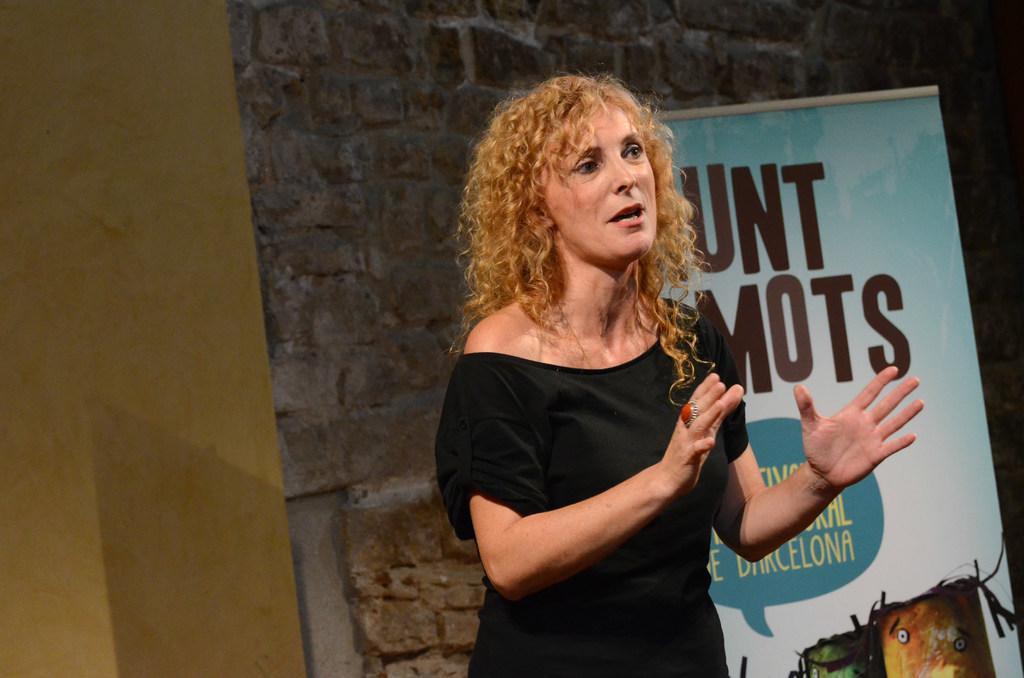Can you describe this image briefly? In this image we can see a person standing and talking. In the background, we can see the banner with text and image near the wall. 